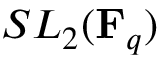<formula> <loc_0><loc_0><loc_500><loc_500>S L _ { 2 } ( F _ { q } )</formula> 